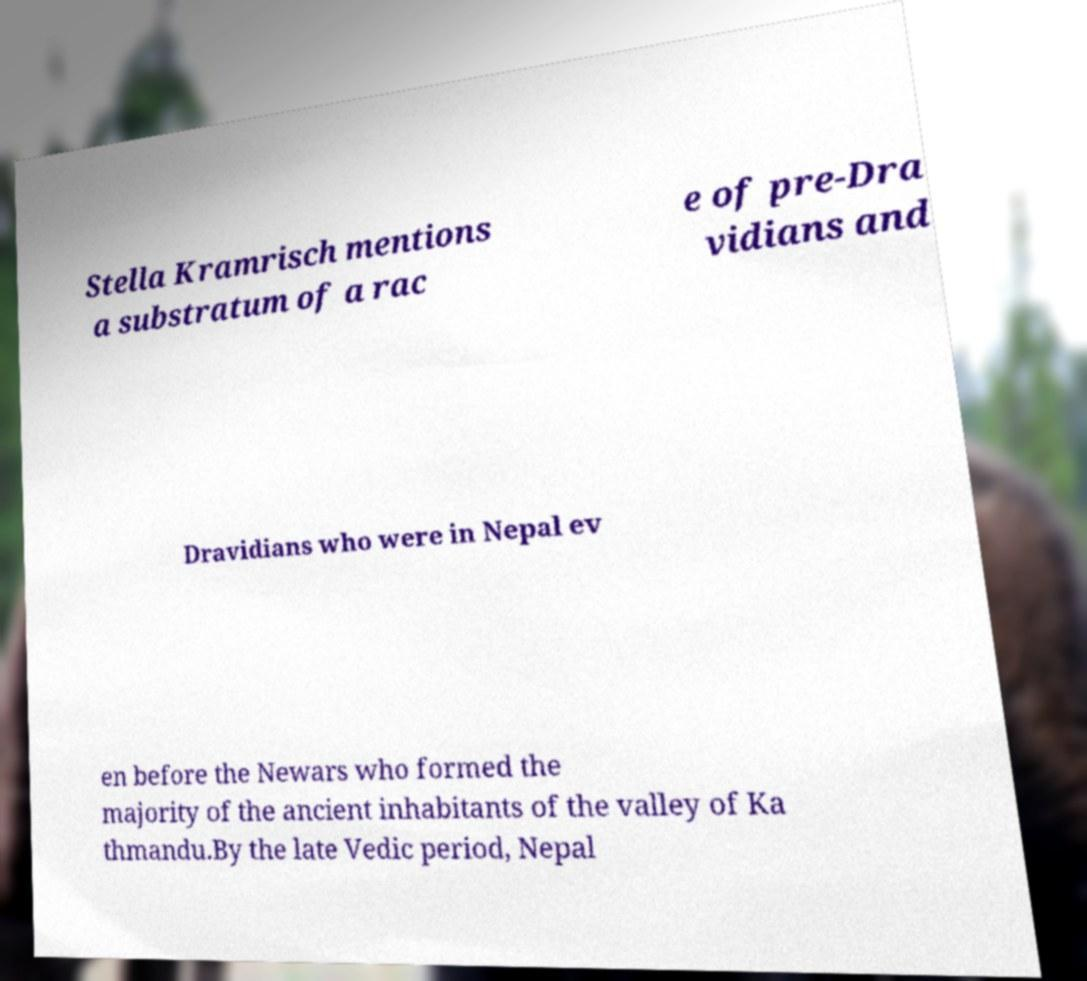Can you read and provide the text displayed in the image?This photo seems to have some interesting text. Can you extract and type it out for me? Stella Kramrisch mentions a substratum of a rac e of pre-Dra vidians and Dravidians who were in Nepal ev en before the Newars who formed the majority of the ancient inhabitants of the valley of Ka thmandu.By the late Vedic period, Nepal 